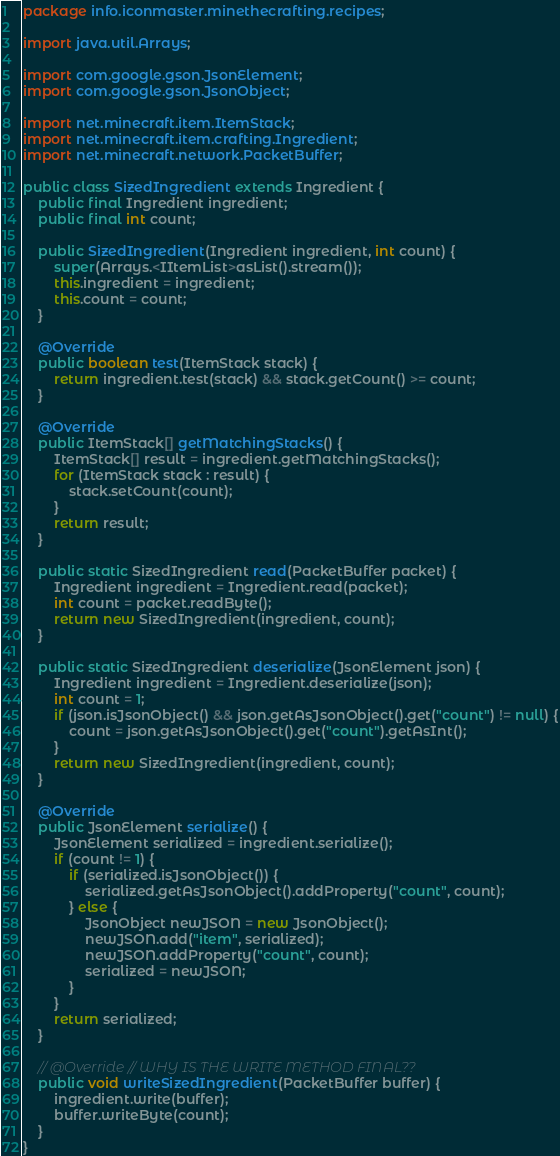<code> <loc_0><loc_0><loc_500><loc_500><_Java_>package info.iconmaster.minethecrafting.recipes;

import java.util.Arrays;

import com.google.gson.JsonElement;
import com.google.gson.JsonObject;

import net.minecraft.item.ItemStack;
import net.minecraft.item.crafting.Ingredient;
import net.minecraft.network.PacketBuffer;

public class SizedIngredient extends Ingredient {
    public final Ingredient ingredient;
    public final int count;

    public SizedIngredient(Ingredient ingredient, int count) {
        super(Arrays.<IItemList>asList().stream());
        this.ingredient = ingredient;
        this.count = count;
    }

    @Override
    public boolean test(ItemStack stack) {
        return ingredient.test(stack) && stack.getCount() >= count;
    }

    @Override
    public ItemStack[] getMatchingStacks() {
        ItemStack[] result = ingredient.getMatchingStacks();
        for (ItemStack stack : result) {
            stack.setCount(count);
        }
        return result;
    }

    public static SizedIngredient read(PacketBuffer packet) {
        Ingredient ingredient = Ingredient.read(packet);
        int count = packet.readByte();
        return new SizedIngredient(ingredient, count);
    }

    public static SizedIngredient deserialize(JsonElement json) {
        Ingredient ingredient = Ingredient.deserialize(json);
        int count = 1;
        if (json.isJsonObject() && json.getAsJsonObject().get("count") != null) {
            count = json.getAsJsonObject().get("count").getAsInt();
        }
        return new SizedIngredient(ingredient, count);
    }

    @Override
    public JsonElement serialize() {
        JsonElement serialized = ingredient.serialize();
        if (count != 1) {
            if (serialized.isJsonObject()) {
                serialized.getAsJsonObject().addProperty("count", count);
            } else {
                JsonObject newJSON = new JsonObject();
                newJSON.add("item", serialized);
                newJSON.addProperty("count", count);
                serialized = newJSON;
            }
        }
        return serialized;
    }

    // @Override // WHY IS THE WRITE METHOD FINAL??
    public void writeSizedIngredient(PacketBuffer buffer) {
        ingredient.write(buffer);
        buffer.writeByte(count);
    }
}
</code> 